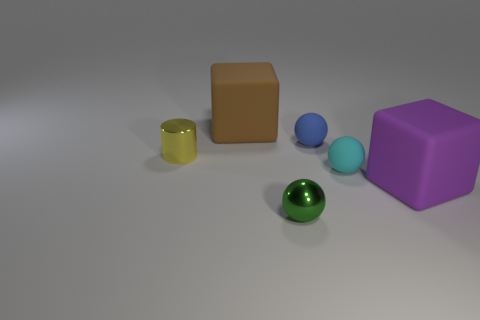How many green objects are shiny balls or big things?
Keep it short and to the point. 1. Is the material of the tiny cyan thing the same as the small cylinder?
Your answer should be very brief. No. Are there the same number of small blue matte balls to the left of the small green sphere and tiny blue matte things that are left of the big purple cube?
Your answer should be compact. No. What is the material of the purple object that is the same shape as the brown thing?
Offer a terse response. Rubber. There is a large object that is in front of the large thing that is to the left of the block on the right side of the green metallic sphere; what shape is it?
Ensure brevity in your answer.  Cube. Is the number of big rubber things that are right of the tiny cyan rubber thing greater than the number of tiny gray metallic cylinders?
Offer a very short reply. Yes. Does the large matte object that is right of the cyan object have the same shape as the cyan rubber thing?
Ensure brevity in your answer.  No. There is a small thing that is on the left side of the green object; what is its material?
Keep it short and to the point. Metal. How many other brown things have the same shape as the large brown rubber object?
Your answer should be compact. 0. There is a sphere that is in front of the big matte thing in front of the small cylinder; what is it made of?
Provide a short and direct response. Metal. 